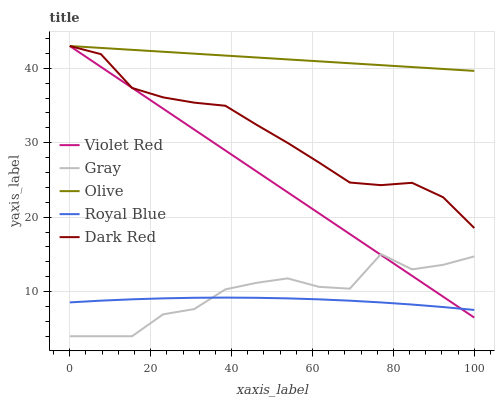Does Royal Blue have the minimum area under the curve?
Answer yes or no. Yes. Does Olive have the maximum area under the curve?
Answer yes or no. Yes. Does Gray have the minimum area under the curve?
Answer yes or no. No. Does Gray have the maximum area under the curve?
Answer yes or no. No. Is Violet Red the smoothest?
Answer yes or no. Yes. Is Gray the roughest?
Answer yes or no. Yes. Is Gray the smoothest?
Answer yes or no. No. Is Violet Red the roughest?
Answer yes or no. No. Does Gray have the lowest value?
Answer yes or no. Yes. Does Violet Red have the lowest value?
Answer yes or no. No. Does Dark Red have the highest value?
Answer yes or no. Yes. Does Gray have the highest value?
Answer yes or no. No. Is Gray less than Olive?
Answer yes or no. Yes. Is Dark Red greater than Royal Blue?
Answer yes or no. Yes. Does Dark Red intersect Violet Red?
Answer yes or no. Yes. Is Dark Red less than Violet Red?
Answer yes or no. No. Is Dark Red greater than Violet Red?
Answer yes or no. No. Does Gray intersect Olive?
Answer yes or no. No. 